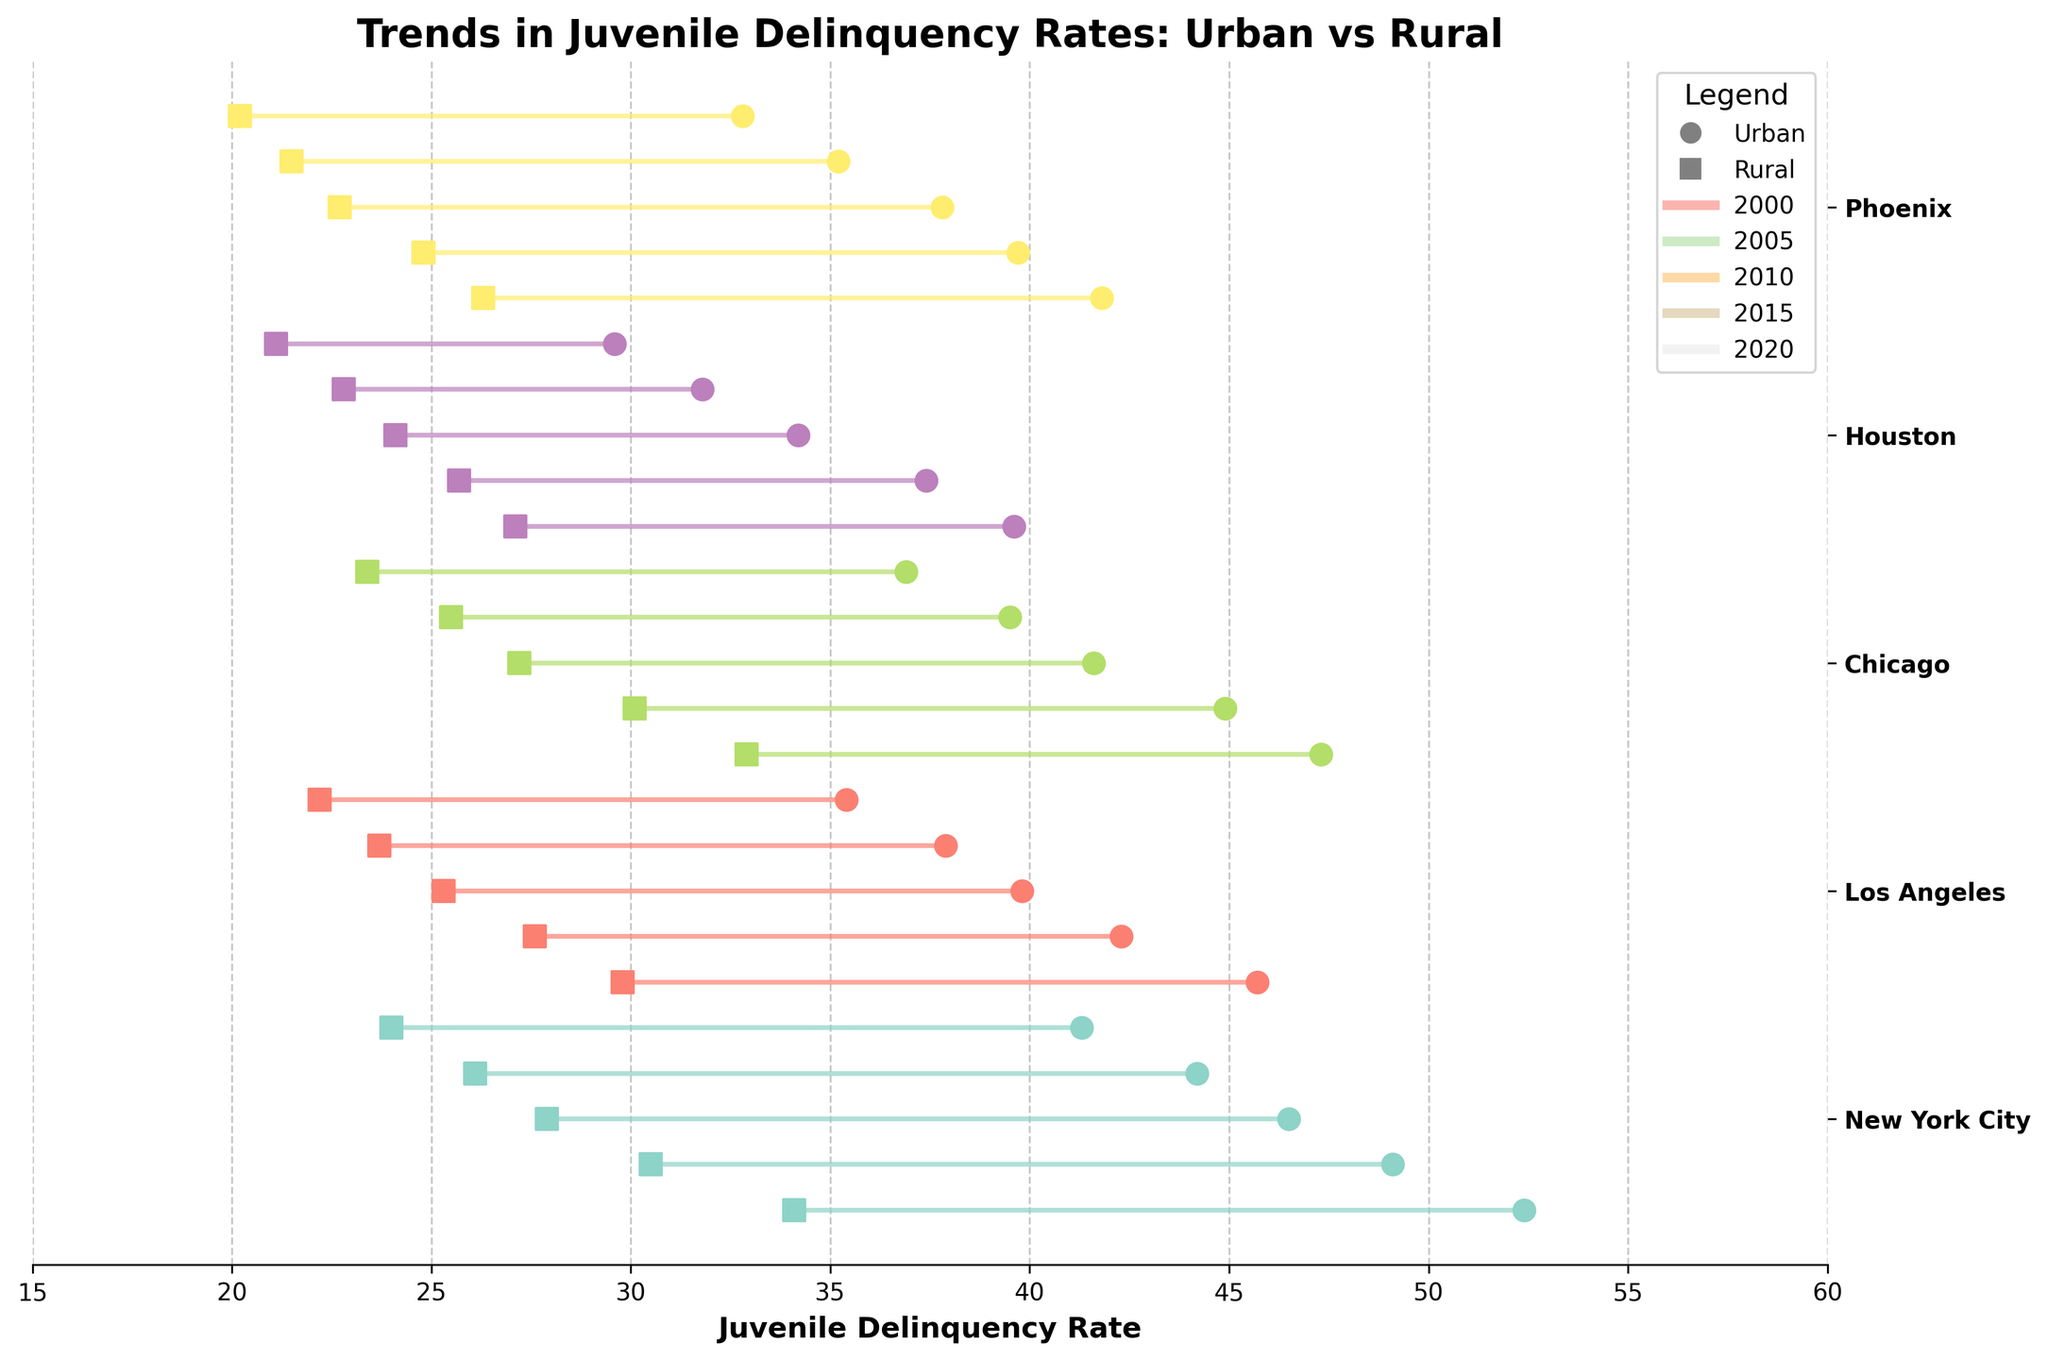How many different years are displayed in the figure? Look at the x-axis and identify the distinct years shown, which are 2000, 2005, 2010, 2015, and 2020. Count them to find there are 5 different years.
Answer: 5 What is the general trend of juvenile delinquency rates in urban areas from 2000 to 2020? Examine the plot lines for urban rates across each location from 2000 to 2020. They generally show a decreasing trend, indicating that urban delinquency rates have been declining over the years.
Answer: Decreasing Which city exhibits the highest urban juvenile delinquency rate in 2000? Look at the urban rate data points for the year 2000 across all the cities. New York City has the highest urban rate at 52.4.
Answer: New York City In which year is the difference between urban and rural rates for Chicago the smallest? Calculate the differences between urban and rural rates for Chicago for each year. The smallest difference, 13.5, occurs in 2020 (36.9 - 23.4).
Answer: 2020 How much did the rural juvenile delinquency rate in New York City decrease from 2000 to 2020? Subtract the rural rate in 2020 (24.0) from the rural rate in 2000 (34.1) to get 34.1 - 24.0 = 10.1.
Answer: 10.1 Which city shows the greatest decline in urban juvenile delinquency rates from 2000 to 2020? Examine the differences in urban rates for each city from 2000 to 2020. Los Angeles shows the greatest decline, dropping from 45.7 to 35.4, a decrease of 10.3.
Answer: Los Angeles What is the average urban juvenile delinquency rate in 2015 across all cities? Add together the urban rates for all cities in 2015 and divide by the number of cities: (44.2 + 37.9 + 39.5 + 31.8 + 35.2) / 5 = 37.72.
Answer: 37.72 Is there any instance where a city's rural juvenile delinquency rate is higher than its urban rate in the same year? Check all the plotted data points for a case where the rural rate exceeds the urban rate for the same city in any year. No such instance is visible.
Answer: No Which city had the smallest rural juvenile delinquency rate in 2000, and what was the rate? Look at the rural rate data points for all cities in the year 2000. Phoenix had the smallest rural rate at 26.3.
Answer: Phoenix, 26.3 How do urban and rural juvenile delinquency rates for Los Angeles compare in 2010? Identify the respective urban and rural rates for Los Angeles in 2010. The urban rate is 39.8, and the rural rate is 25.3, making the difference 14.5.
Answer: Urban rate is higher by 14.5 